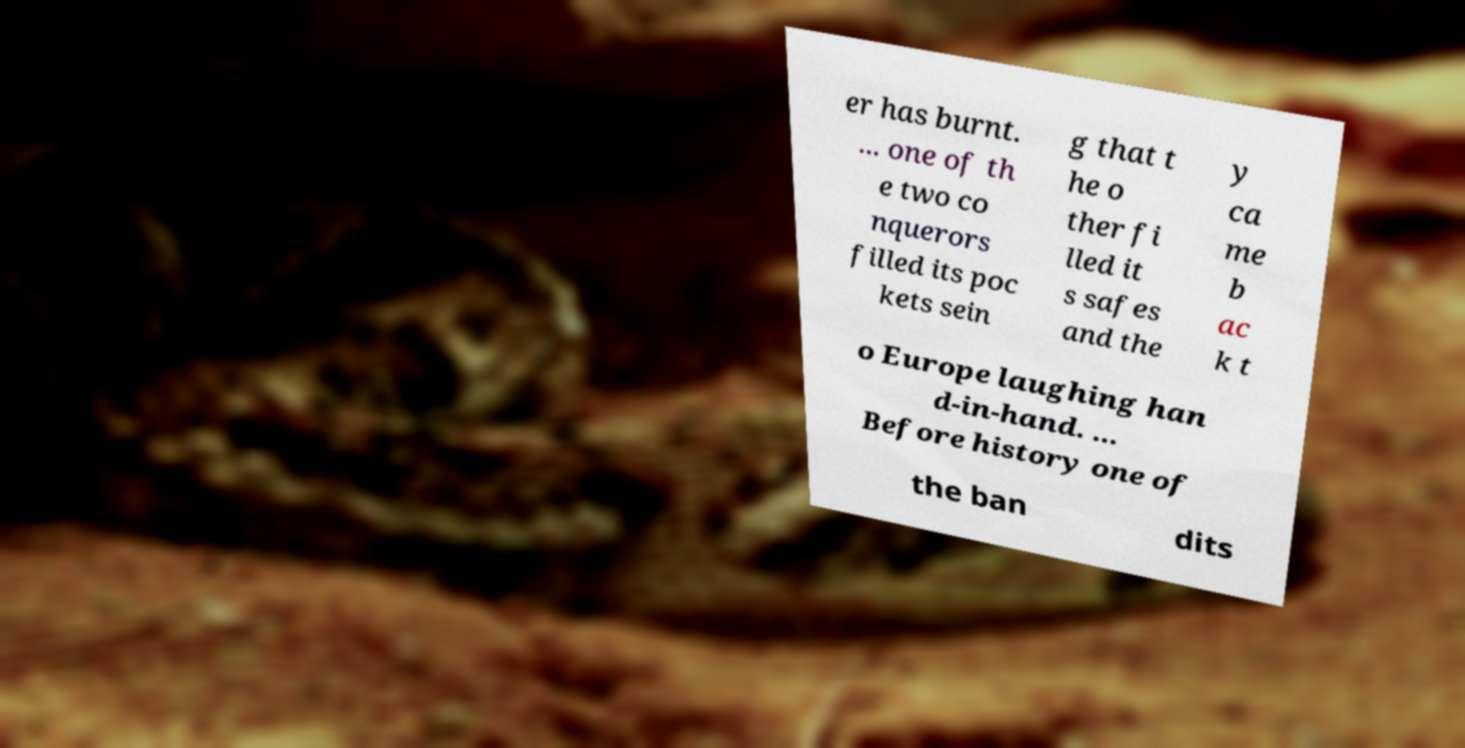Could you assist in decoding the text presented in this image and type it out clearly? er has burnt. ... one of th e two co nquerors filled its poc kets sein g that t he o ther fi lled it s safes and the y ca me b ac k t o Europe laughing han d-in-hand. ... Before history one of the ban dits 